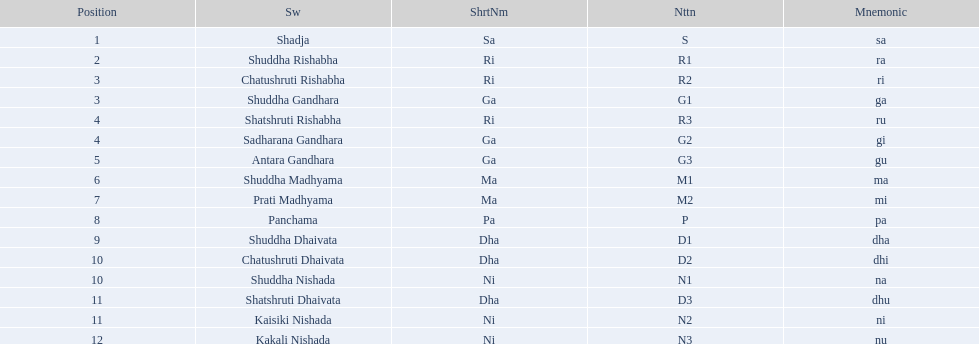Which swara follows immediately after antara gandhara? Shuddha Madhyama. 